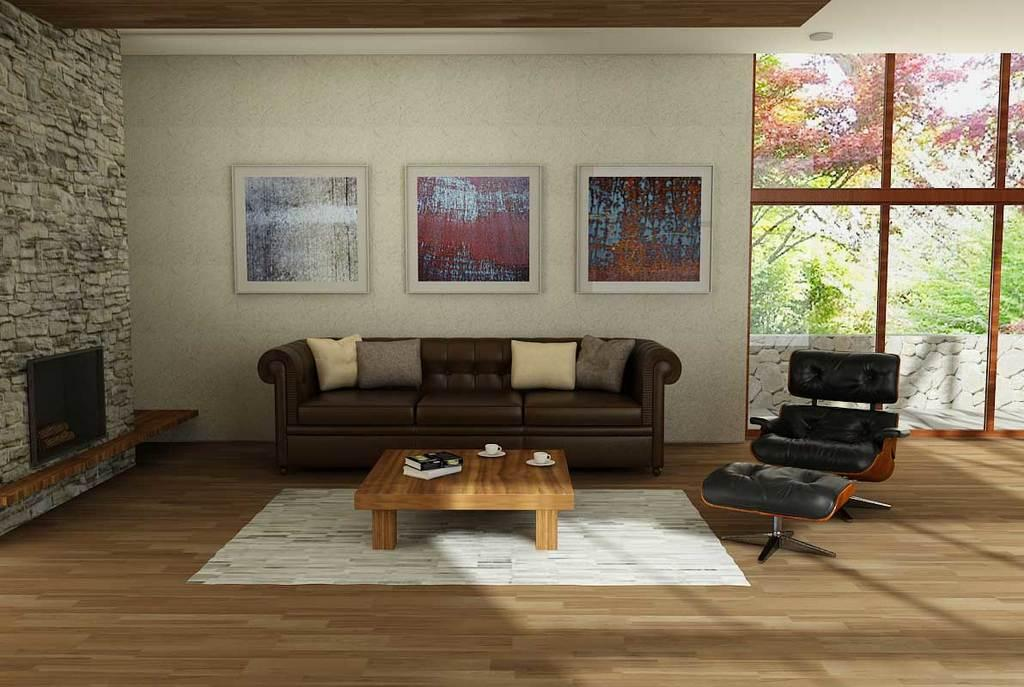What type of furniture is present in the image? There is a sofa and a table in the image. What type of electronic device is present in the image? There is a television in the image. How many cups are visible in the image? There are two cups in the image. How many books are visible in the image? There are two books in the image. What is hanging on the wall in the image? There are frames on the wall in the image. What can be seen in the background of the image? There are trees visible in the background of the image. What advertisement can be seen on the television in the image? There is no advertisement visible on the television in the image; it is not turned on or displaying any content. How many crows are sitting on the sofa in the image? There are no crows present in the image; only the sofa, table, television, cups, books, frames, and trees are visible. 